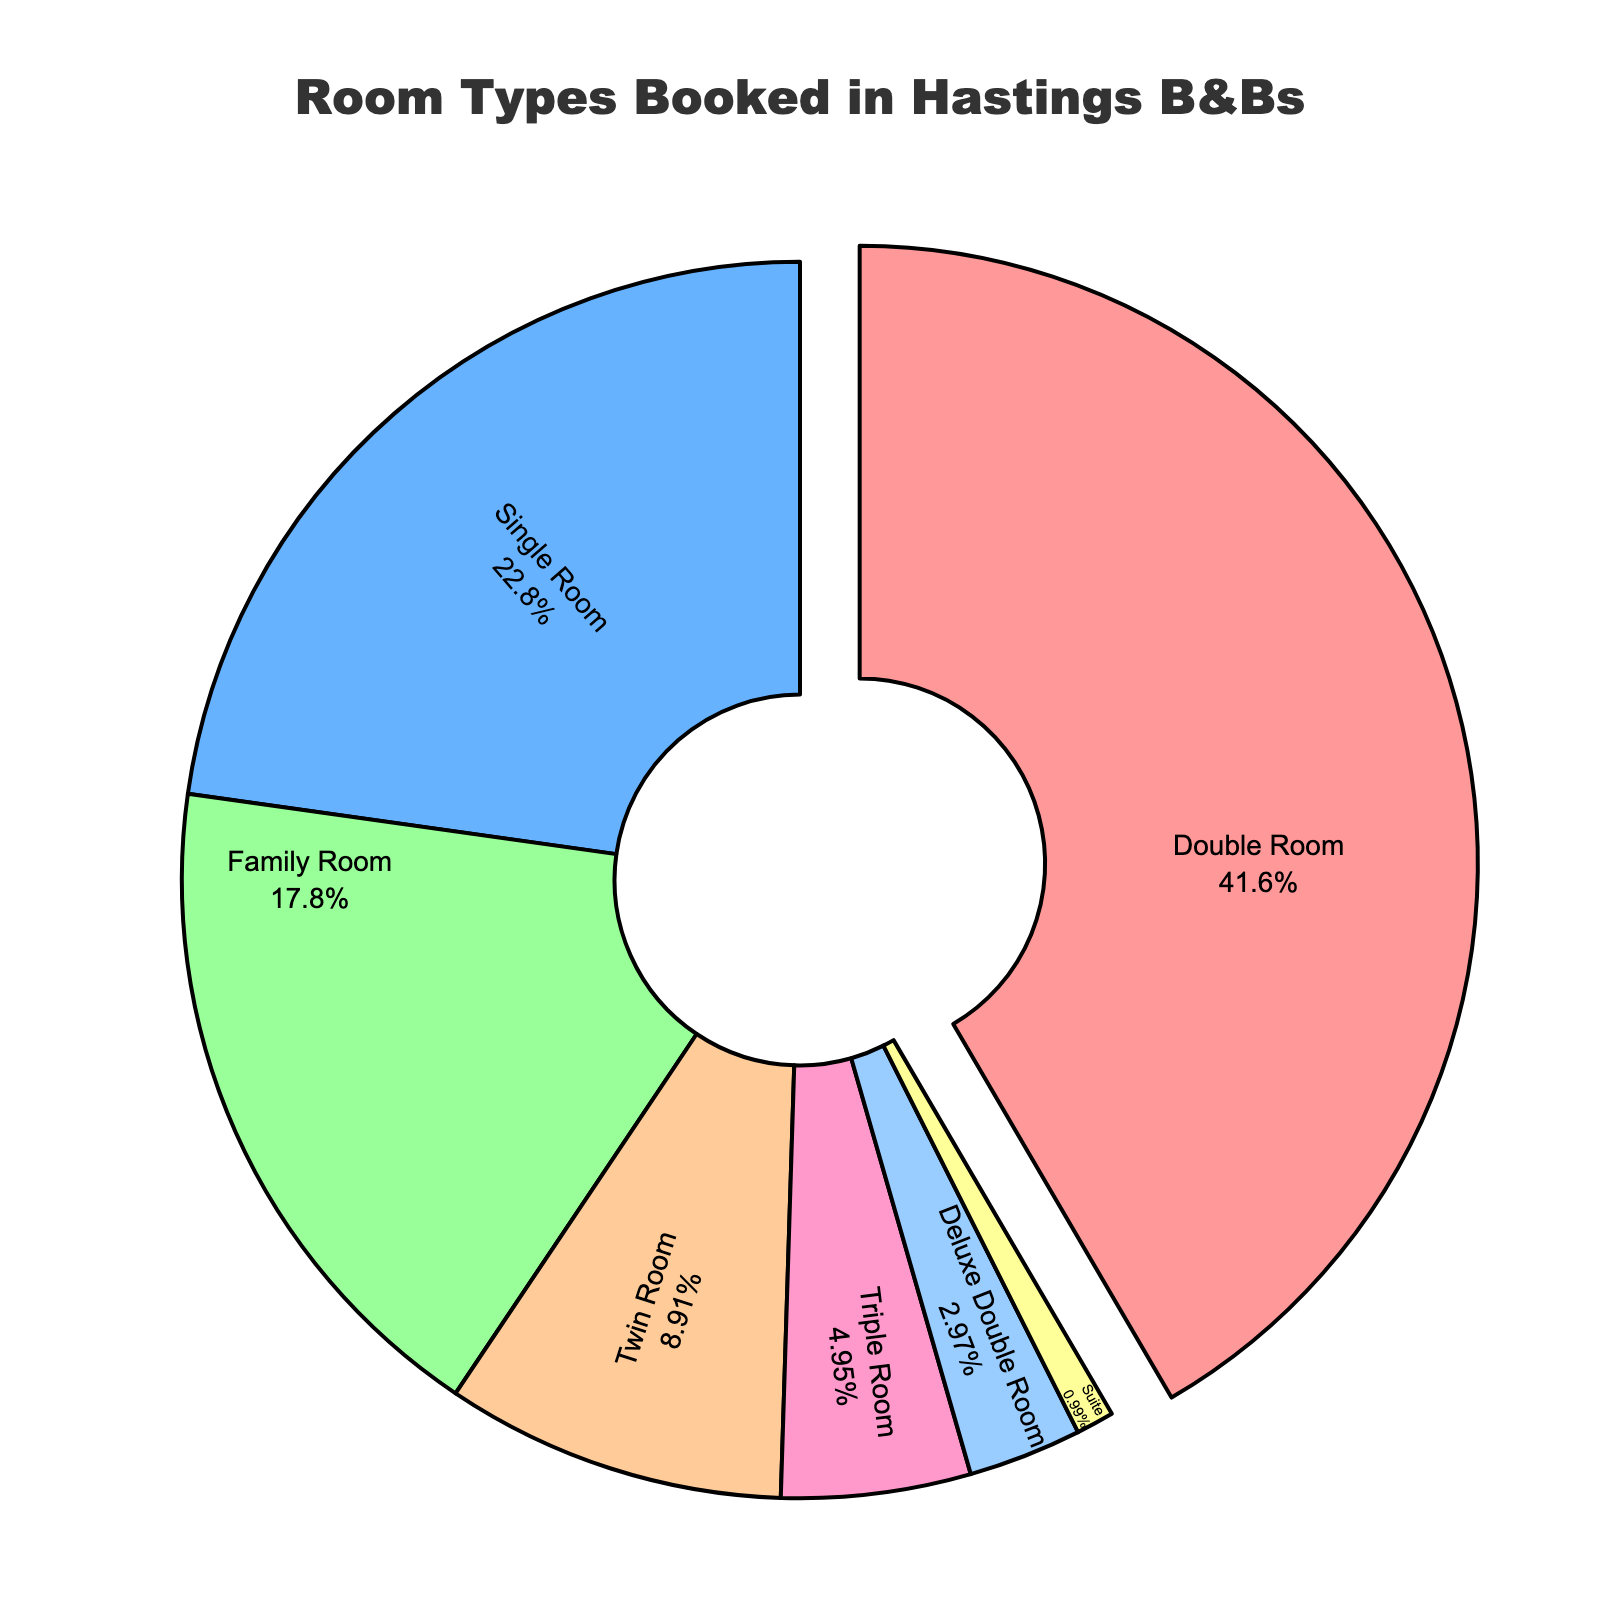What percentage of bookings were for Double Rooms and Single Rooms combined? To find the combined percentage of Double Rooms and Single Rooms, add their individual percentages: Double Room (42%) + Single Room (23%) = 65%
Answer: 65% Which room type had the highest percentage of bookings? The room type with the highest percentage of bookings is the one with the largest slice in the pie chart. Here, it is the Double Room at 42%.
Answer: Double Room Are Triple Rooms more or less popular than Family Rooms? To determine this, compare the percentages of Triple Rooms (5%) and Family Rooms (18%). Triple Rooms have a lower percentage than Family Rooms.
Answer: Less What is the combined percentage of bookings for room types with less than 10% each? Sum the percentages of room types with less than 10%: Twin Room (9%) + Triple Room (5%) + Deluxe Double Room (3%) + Suite (1%) = 18%
Answer: 18% Which room type has the smallest representation in the bookings? The smallest slice in the pie chart represents the room type with the smallest percentage of bookings. In this case, it is the Suite with 1%.
Answer: Suite By how much does the percentage of bookings for Family Rooms exceed that of Twin Rooms? Subtract the percentage of Twin Rooms from that of Family Rooms: Family Room (18%) - Twin Room (9%) = 9%
Answer: 9% What is the approximate fraction of Double Room bookings out of the total? Convert the percentage of Double Room bookings into a fraction: 42% is approximately 42/100, or simplified, 21/50.
Answer: 21/50 Which room types combined make up less than 10% of bookings each and what's their total combined percentage? Identify room types with less than 10% and sum their percentages: Triple Room (5%) + Deluxe Double Room (3%) + Suite (1%) = 9%
Answer: 9% 